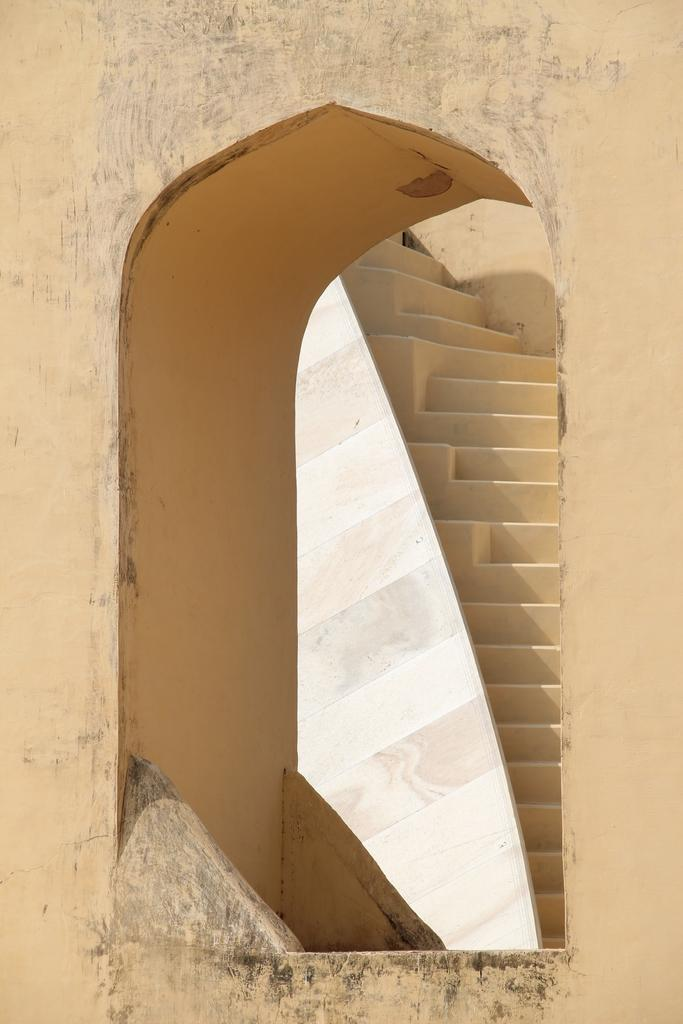What type of structure can be seen in the image? There is a wall in the image. What architectural feature is visible in the background of the image? There are stairs visible in the background of the image. What type of care is being provided to the organization in the image? There is no indication of any care being provided to an organization in the image; it only features a wall and stairs. What type of ball is visible in the image? There is no ball present in the image. 